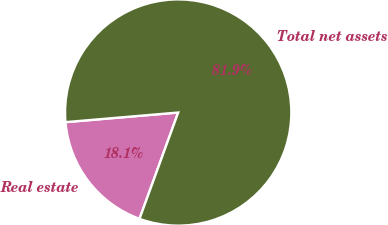Convert chart to OTSL. <chart><loc_0><loc_0><loc_500><loc_500><pie_chart><fcel>Real estate<fcel>Total net assets<nl><fcel>18.09%<fcel>81.91%<nl></chart> 